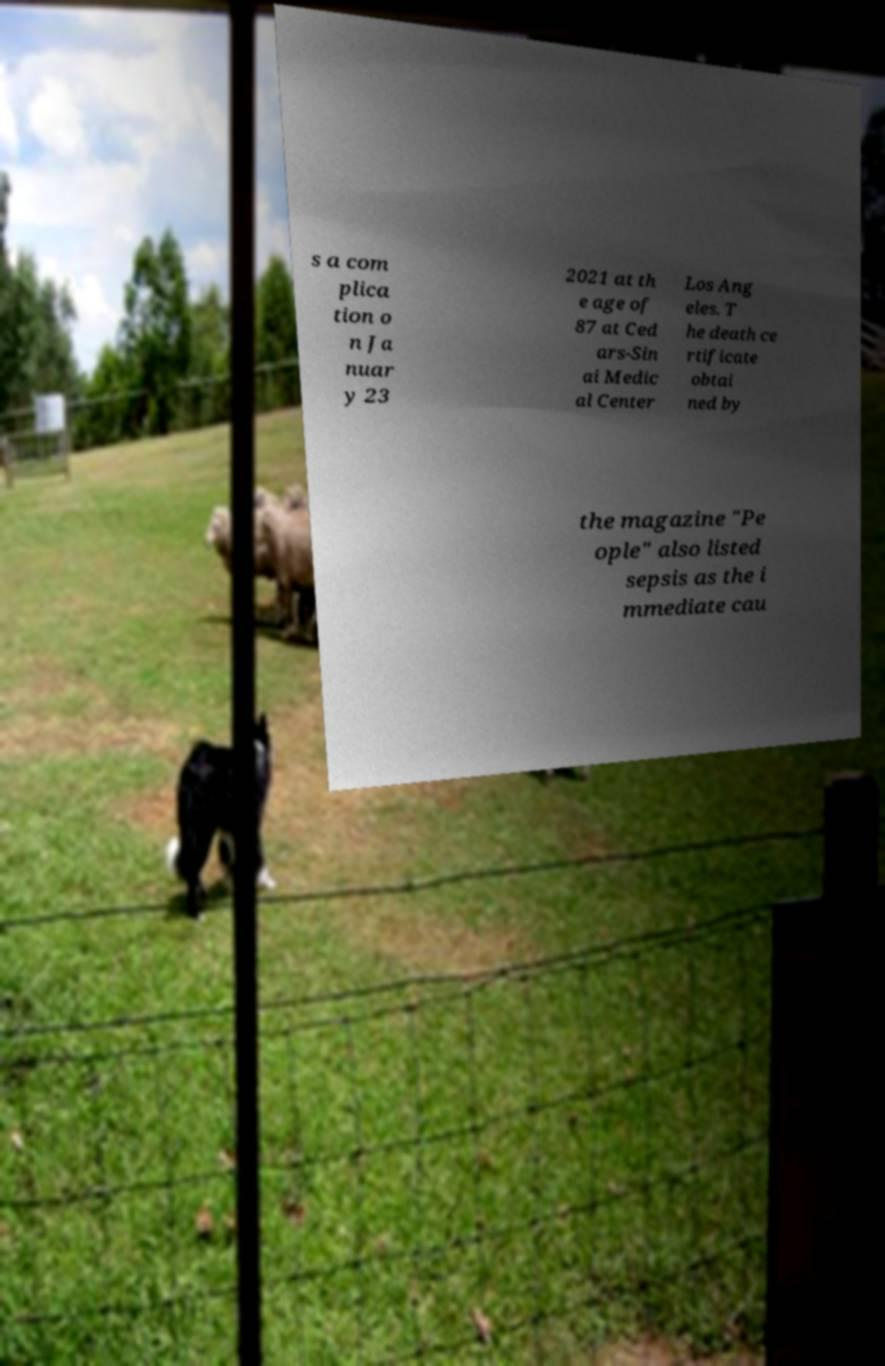What messages or text are displayed in this image? I need them in a readable, typed format. s a com plica tion o n Ja nuar y 23 2021 at th e age of 87 at Ced ars-Sin ai Medic al Center Los Ang eles. T he death ce rtificate obtai ned by the magazine "Pe ople" also listed sepsis as the i mmediate cau 